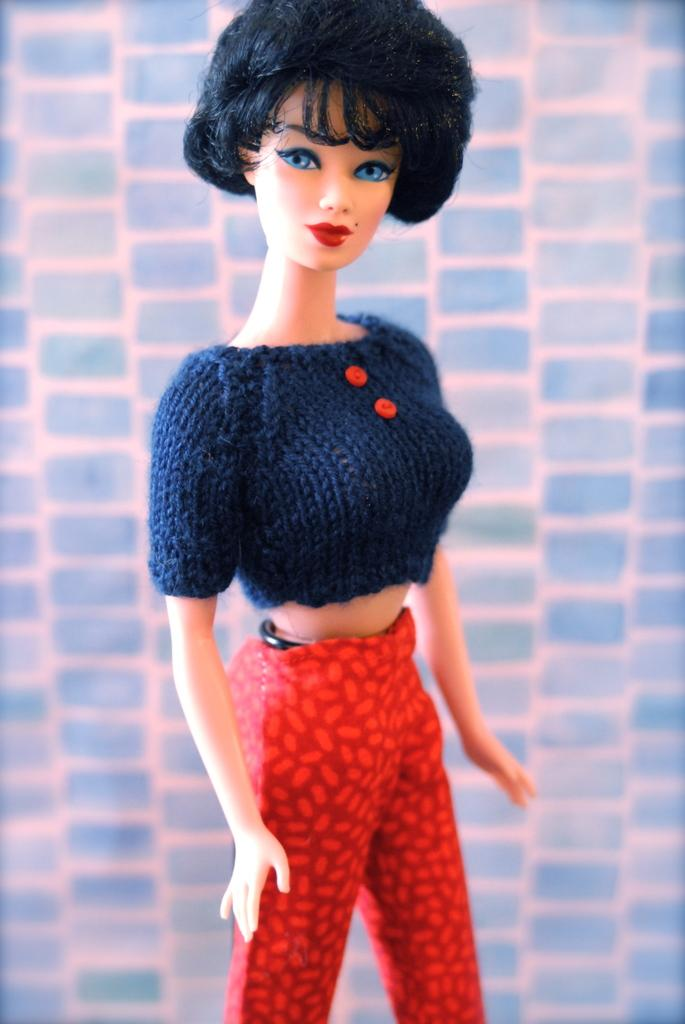What is the main subject of the image? The main subject of the image is a doll of a girl. Can you describe the doll in the image? The doll is of a girl. What type of zephyr is the girl doll holding in the image? There is no zephyr present in the image; it is a doll of a girl. How many people are in the company of the girl doll in the image? There are no other people present in the image; it is a doll of a girl by itself. 